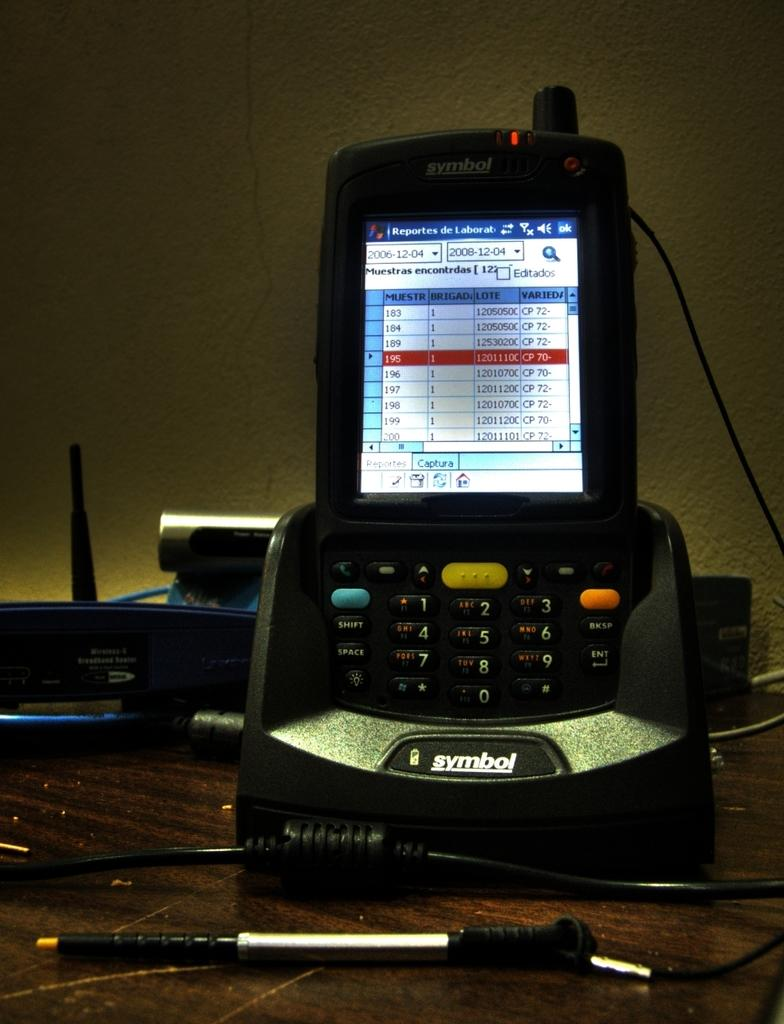<image>
Write a terse but informative summary of the picture. A phone screen is open to a labor reports page that is in Spanish. 